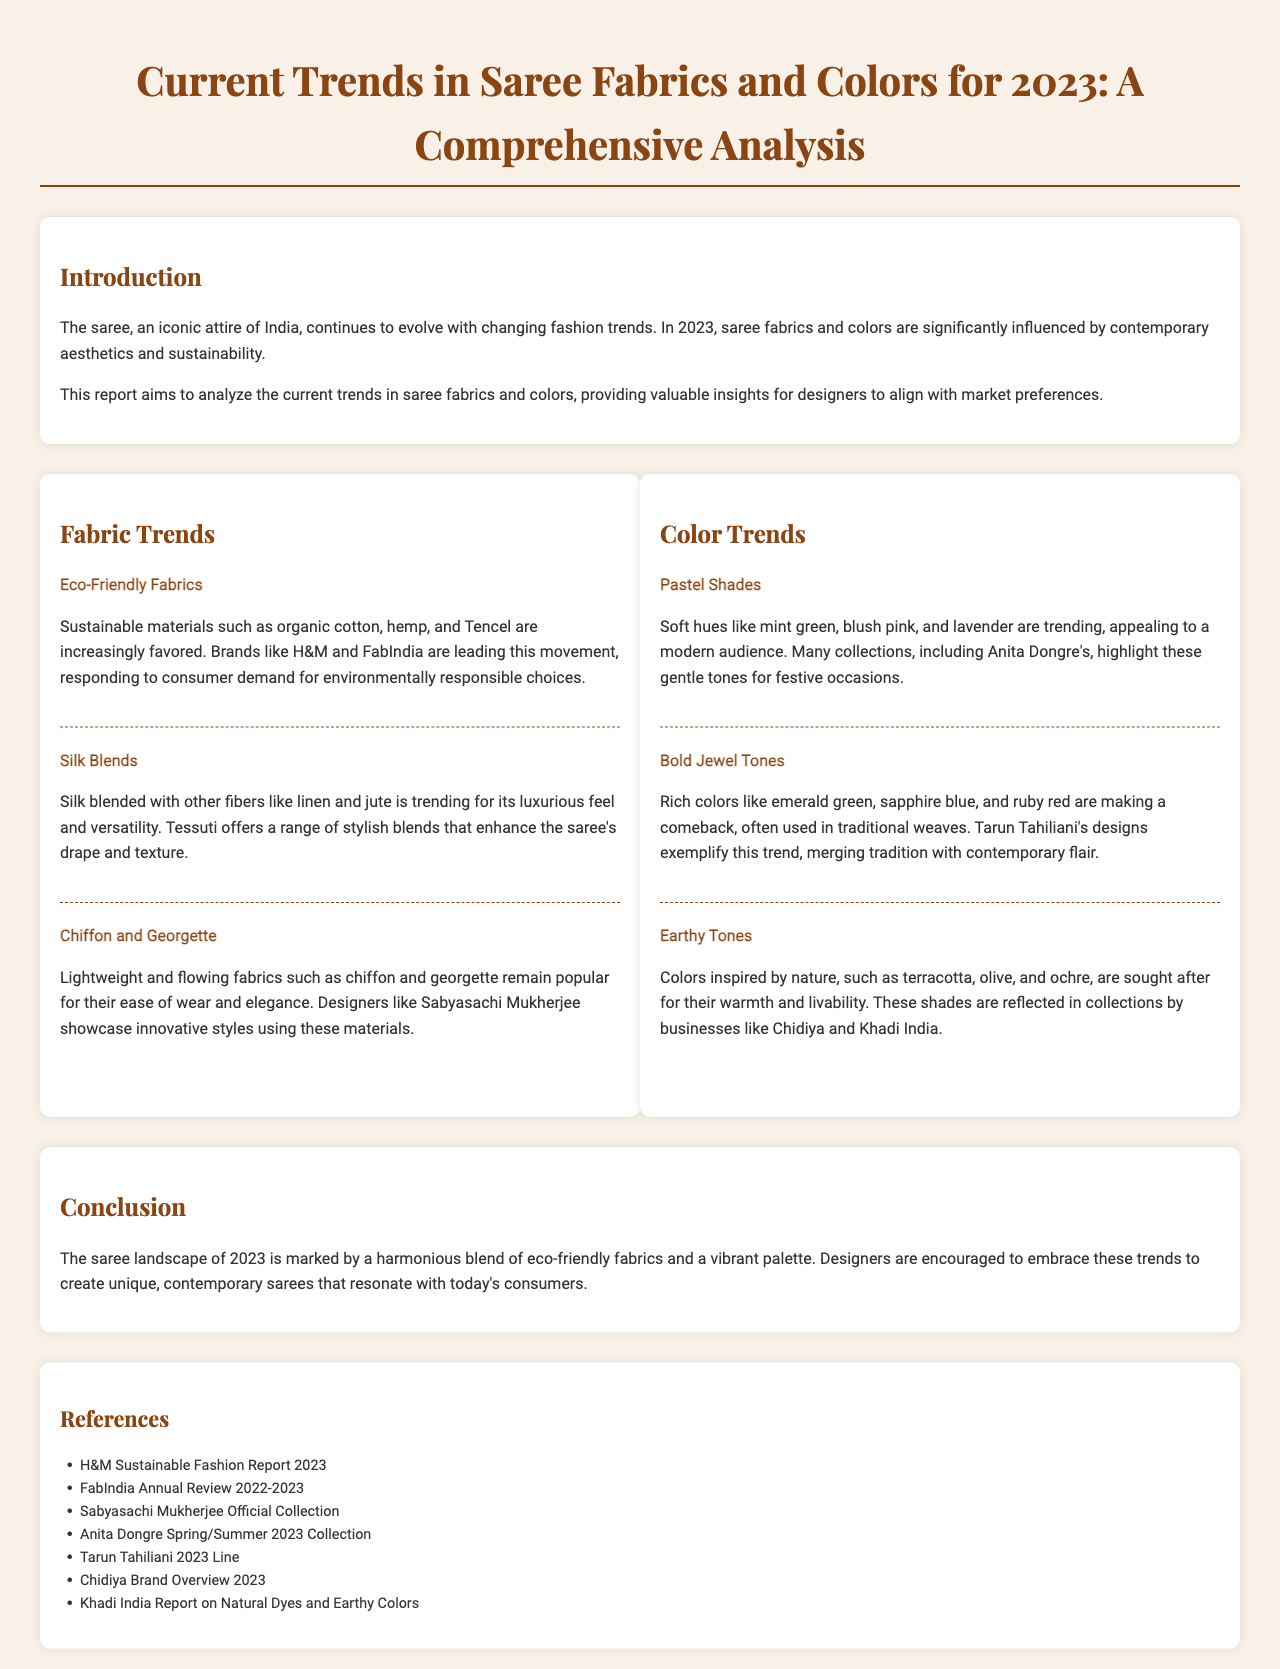What are the three fabric trends mentioned? The fabric trends listed in the document are Eco-Friendly Fabrics, Silk Blends, and Chiffon and Georgette.
Answer: Eco-Friendly Fabrics, Silk Blends, Chiffon and Georgette Which color is associated with nature? The document associates earthy tones with nature, which include colors inspired by natural elements.
Answer: Earthy Tones Who is mentioned as showcasing innovative styles with chiffon and georgette? Sabyasachi Mukherjee is identified in the document as a designer showcasing styles using chiffon and georgette.
Answer: Sabyasachi Mukherjee What year do the trends apply to? The trends discussed in the document are specifically for the year 2023.
Answer: 2023 Which brand is known for its range of sustainable materials? The document mentions H&M as a leading brand in the movement toward sustainable materials.
Answer: H&M What types of colors are highlighted for festive occasions? The document highlights pastel shades as the colors appealing to a modern audience for festive occasions.
Answer: Pastel Shades What is the focus of the report? The focus of the report is to analyze current trends in saree fabrics and colors.
Answer: Current trends in saree fabrics and colors Which type of shades are making a comeback according to the document? Bold jewel tones like emerald green, sapphire blue, and ruby red are mentioned as making a comeback in saree designs.
Answer: Bold Jewel Tones 